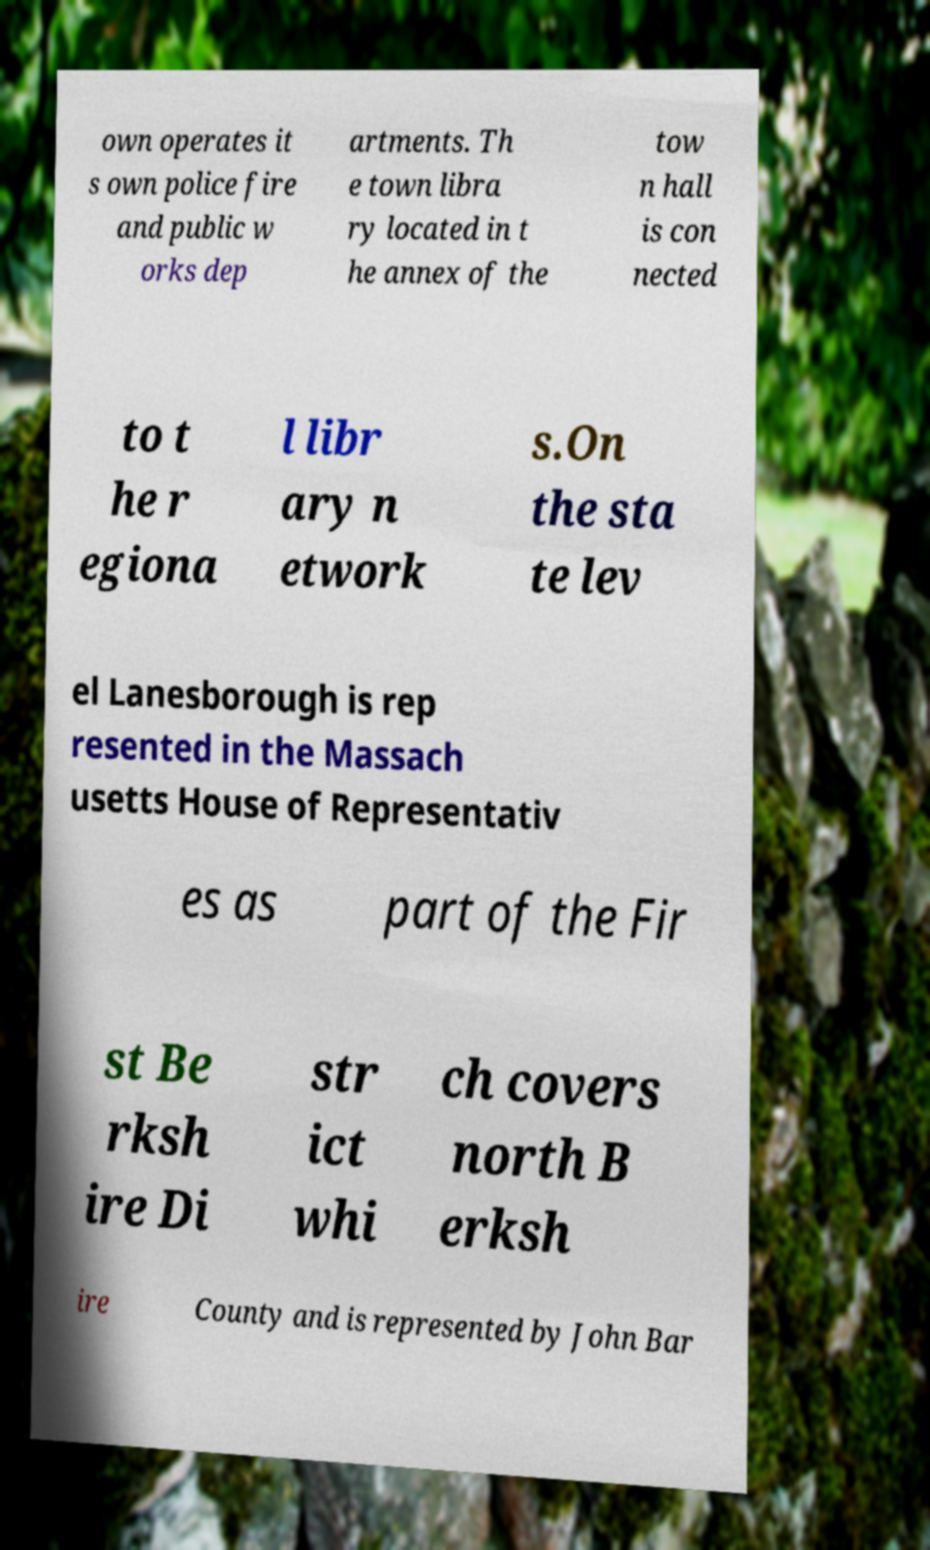I need the written content from this picture converted into text. Can you do that? own operates it s own police fire and public w orks dep artments. Th e town libra ry located in t he annex of the tow n hall is con nected to t he r egiona l libr ary n etwork s.On the sta te lev el Lanesborough is rep resented in the Massach usetts House of Representativ es as part of the Fir st Be rksh ire Di str ict whi ch covers north B erksh ire County and is represented by John Bar 